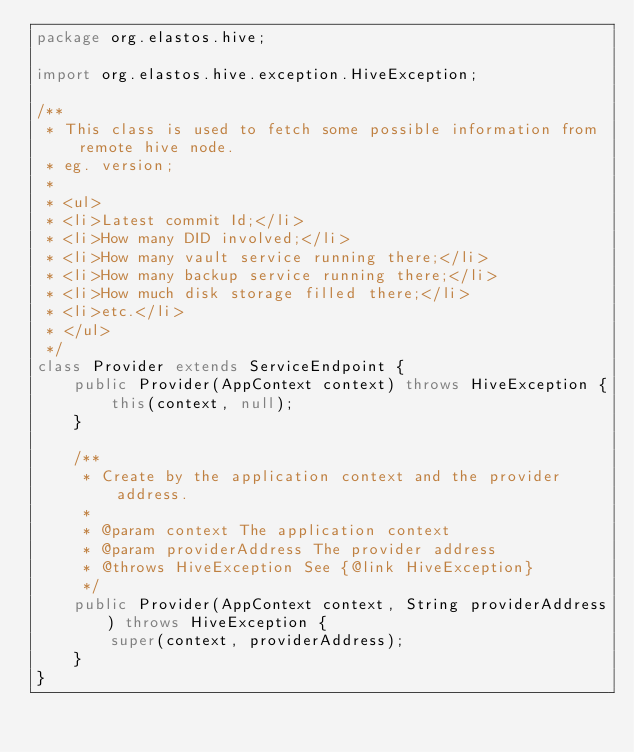Convert code to text. <code><loc_0><loc_0><loc_500><loc_500><_Java_>package org.elastos.hive;

import org.elastos.hive.exception.HiveException;

/**
 * This class is used to fetch some possible information from remote hive node.
 * eg. version;
 *
 * <ul>
 * <li>Latest commit Id;</li>
 * <li>How many DID involved;</li>
 * <li>How many vault service running there;</li>
 * <li>How many backup service running there;</li>
 * <li>How much disk storage filled there;</li>
 * <li>etc.</li>
 * </ul>
 */
class Provider extends ServiceEndpoint {
	public Provider(AppContext context) throws HiveException {
		this(context, null);
	}

	/**
	 * Create by the application context and the provider address.
	 *
	 * @param context The application context
	 * @param providerAddress The provider address
	 * @throws HiveException See {@link HiveException}
	 */
	public Provider(AppContext context, String providerAddress) throws HiveException {
		super(context, providerAddress);
	}
}
</code> 